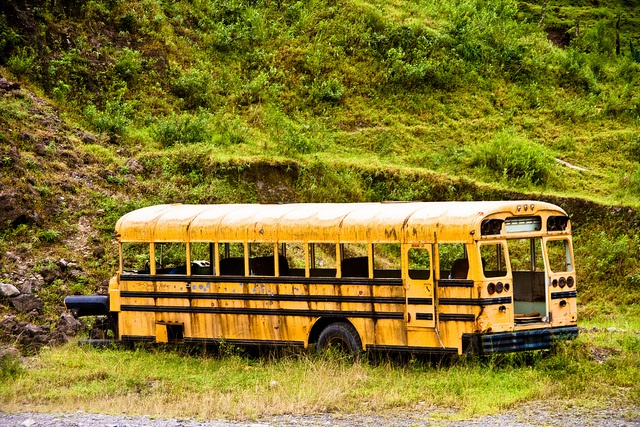Describe the objects in this image and their specific colors. I can see bus in black, orange, ivory, and olive tones in this image. 